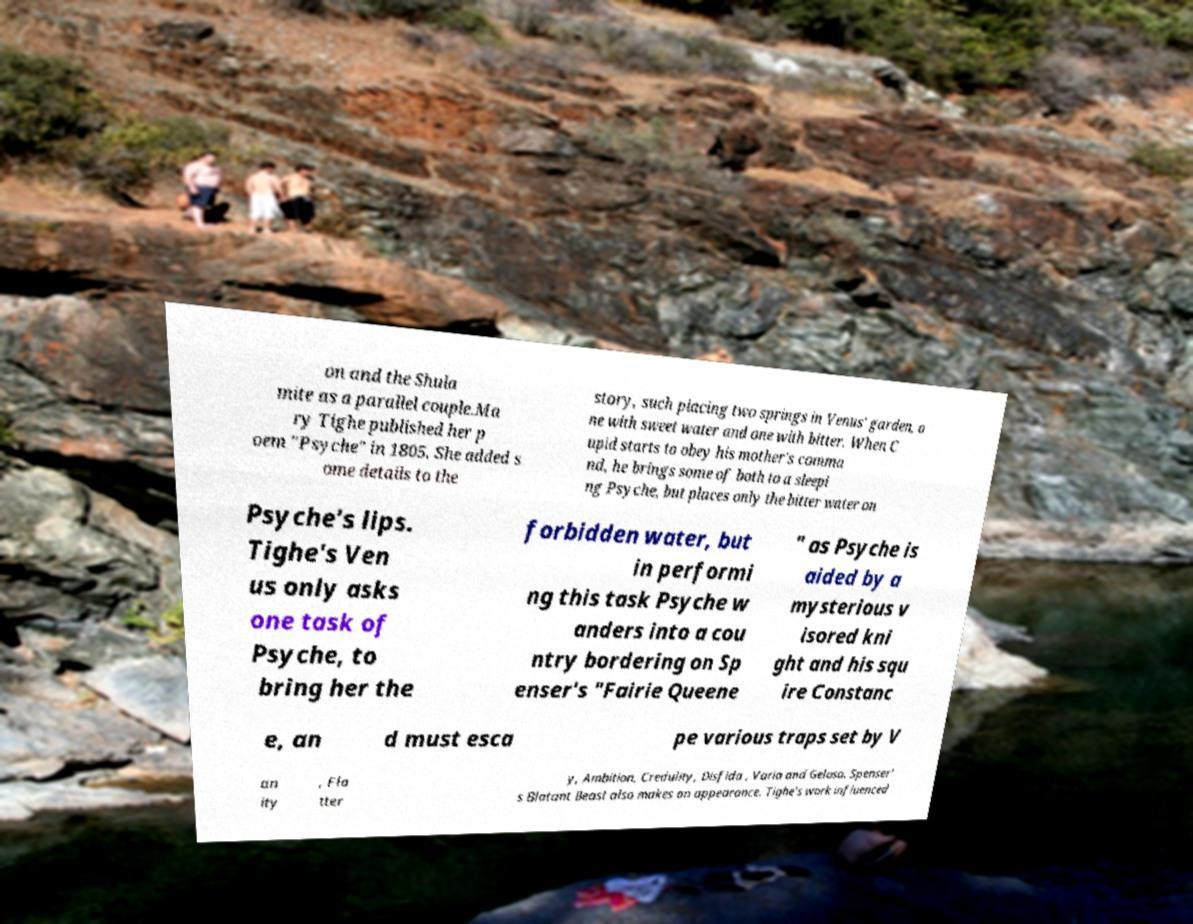There's text embedded in this image that I need extracted. Can you transcribe it verbatim? on and the Shula mite as a parallel couple.Ma ry Tighe published her p oem "Psyche" in 1805. She added s ome details to the story, such placing two springs in Venus' garden, o ne with sweet water and one with bitter. When C upid starts to obey his mother's comma nd, he brings some of both to a sleepi ng Psyche, but places only the bitter water on Psyche's lips. Tighe's Ven us only asks one task of Psyche, to bring her the forbidden water, but in performi ng this task Psyche w anders into a cou ntry bordering on Sp enser's "Fairie Queene " as Psyche is aided by a mysterious v isored kni ght and his squ ire Constanc e, an d must esca pe various traps set by V an ity , Fla tter y, Ambition, Credulity, Disfida , Varia and Geloso. Spenser' s Blatant Beast also makes an appearance. Tighe's work influenced 